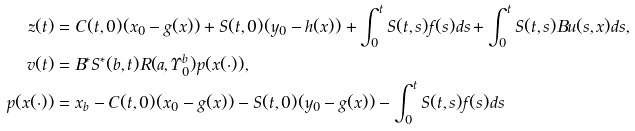Convert formula to latex. <formula><loc_0><loc_0><loc_500><loc_500>z ( t ) & = C ( t , 0 ) ( x _ { 0 } - g ( x ) ) + S ( t , 0 ) ( y _ { 0 } - h ( x ) ) + \int _ { 0 } ^ { t } S ( t , s ) f ( s ) d s + \int _ { 0 } ^ { t } S ( t , s ) B u ( s , x ) d s , \\ v ( t ) & = B ^ { * } S ^ { * } ( b , t ) R ( a , \Upsilon _ { 0 } ^ { b } ) p ( x ( \cdot ) ) , \\ p ( x ( \cdot ) ) & = x _ { b } - C ( t , 0 ) ( x _ { 0 } - g ( x ) ) - S ( t , 0 ) ( y _ { 0 } - g ( x ) ) - \int _ { 0 } ^ { t } S ( t , s ) f ( s ) d s</formula> 